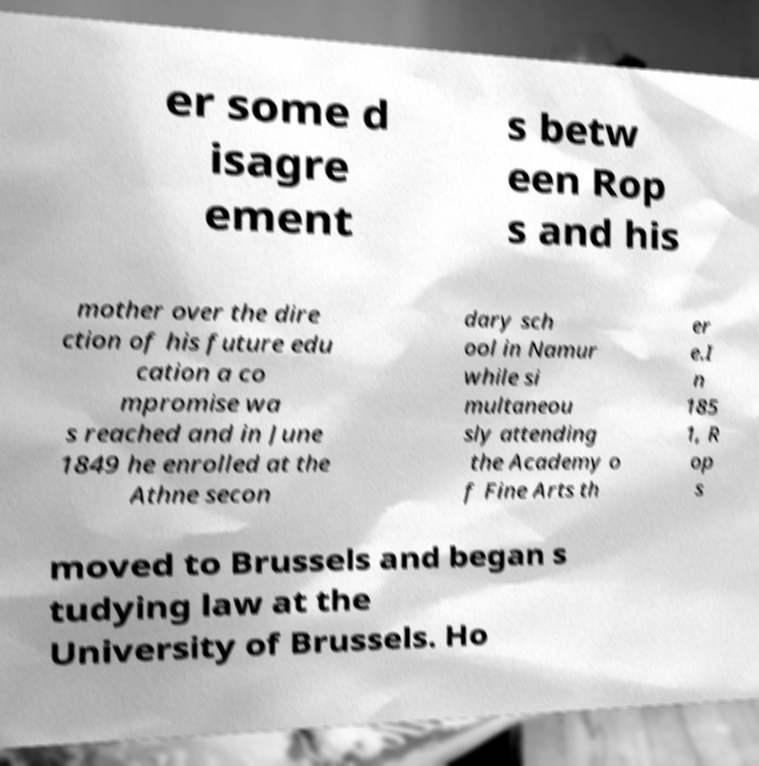Could you extract and type out the text from this image? er some d isagre ement s betw een Rop s and his mother over the dire ction of his future edu cation a co mpromise wa s reached and in June 1849 he enrolled at the Athne secon dary sch ool in Namur while si multaneou sly attending the Academy o f Fine Arts th er e.I n 185 1, R op s moved to Brussels and began s tudying law at the University of Brussels. Ho 